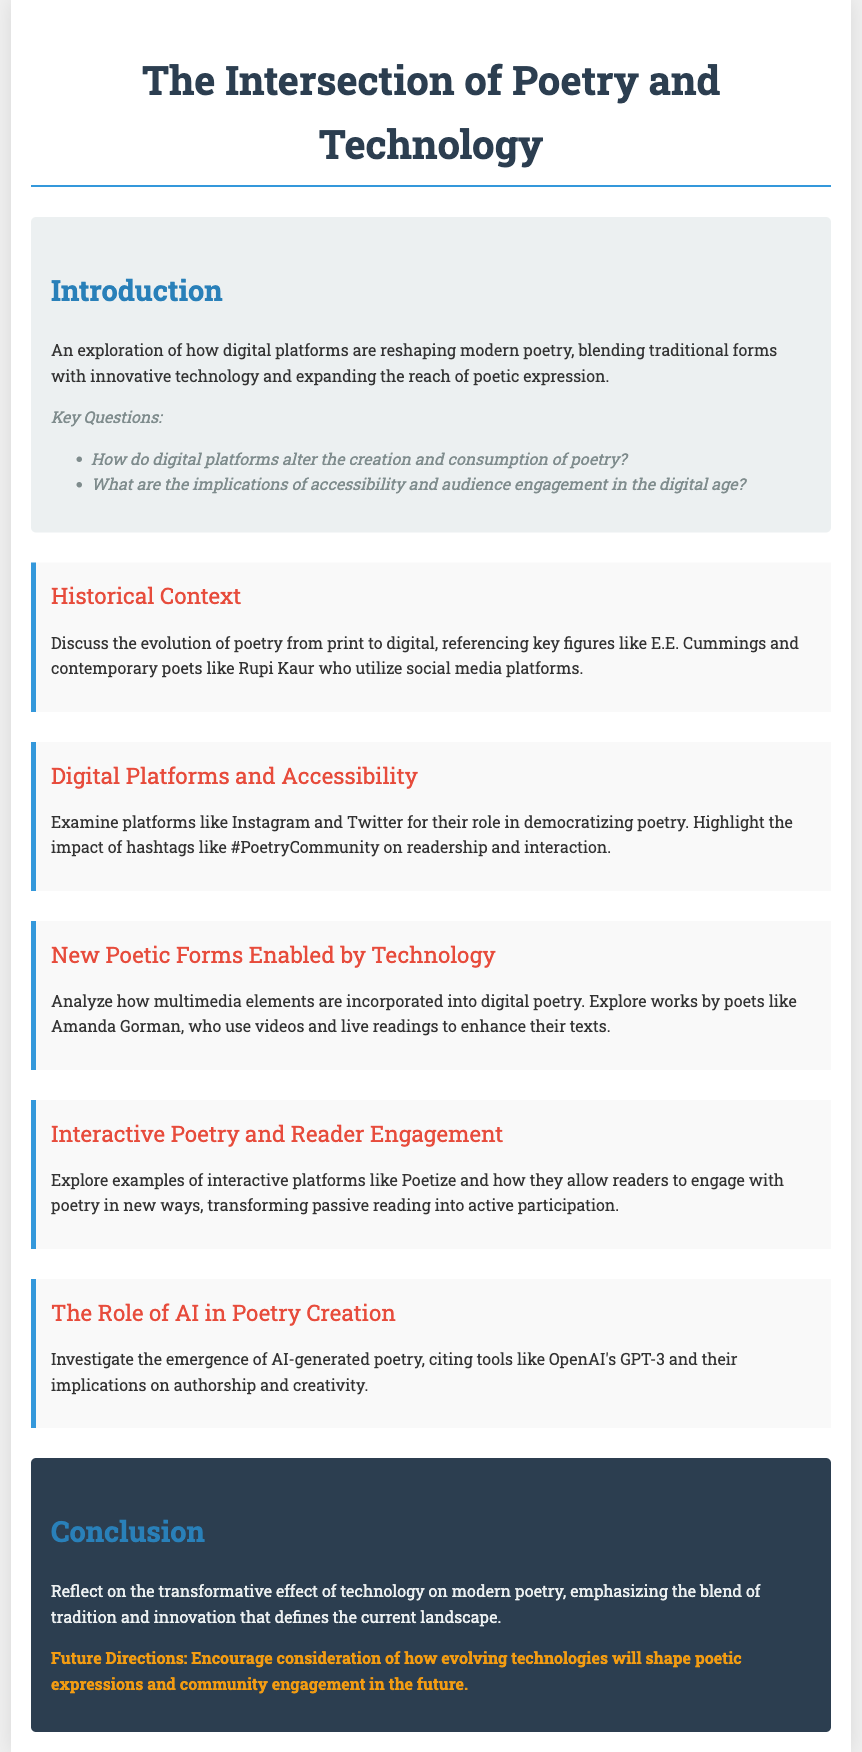What are the key questions addressed in the introduction? The introduction lists key questions about digital platforms' impact on poetry creation and consumption.
Answer: How do digital platforms alter the creation and consumption of poetry? What are the implications of accessibility and audience engagement in the digital age? Who are the key figures referenced in the historical context? The historical context mentions E.E. Cummings and contemporary poet Rupi Kaur.
Answer: E.E. Cummings and Rupi Kaur Which digital platforms are highlighted for their role in democratizing poetry? The document specifically mentions Instagram and Twitter.
Answer: Instagram and Twitter What is the significance of hashtags like #PoetryCommunity? The document highlights their role in enhancing readership and interaction within the poetry community.
Answer: Enhancing readership and interaction Which poet is noted for using multimedia elements in their works? The section on new poetic forms mentions Amanda Gorman as an example.
Answer: Amanda Gorman What kind of interaction do platforms like Poetize encourage? The document states that these platforms transform passive reading into active participation.
Answer: Active participation What tool is cited for the emergence of AI-generated poetry? The document refers to OpenAI's GPT-3 as an example of AI poetry creation tools.
Answer: OpenAI's GPT-3 What is emphasized about the current landscape of modern poetry in the conclusion? The conclusion reflects on the transformative effect of technology, blending tradition and innovation in poetry.
Answer: Blend of tradition and innovation 